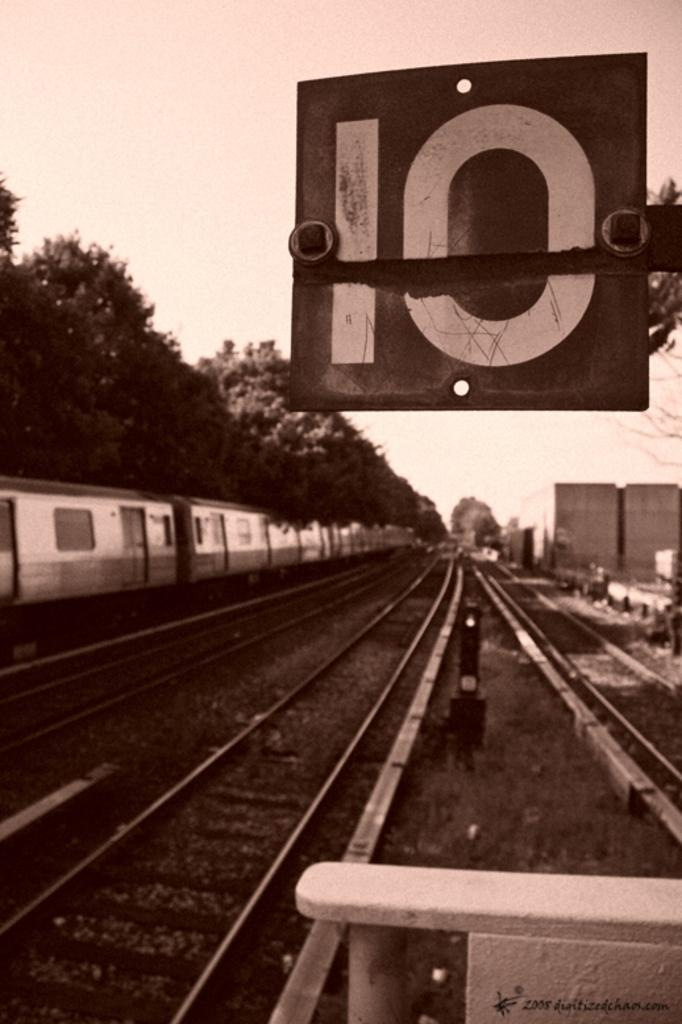<image>
Write a terse but informative summary of the picture. A sign with the number 10 hangs over railroad tracks. 